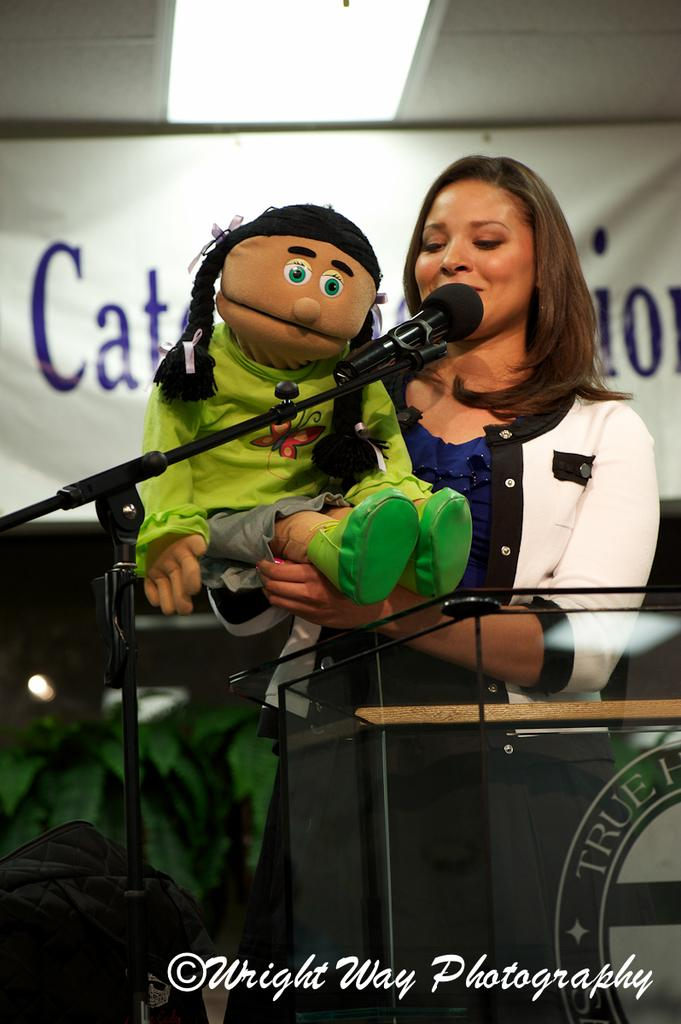Who is the main subject in the image? There is a woman in the image. What is the woman holding in the image? The woman is holding a toy. Where is the woman standing in the image? The woman is standing in front of a podium. What is the woman likely to use in the image? The woman is likely to use the microphone in front of her. What can be seen in the background of the image? There is a pompom and a light in the background of the image. What direction is the book facing in the image? There is no book present in the image. 